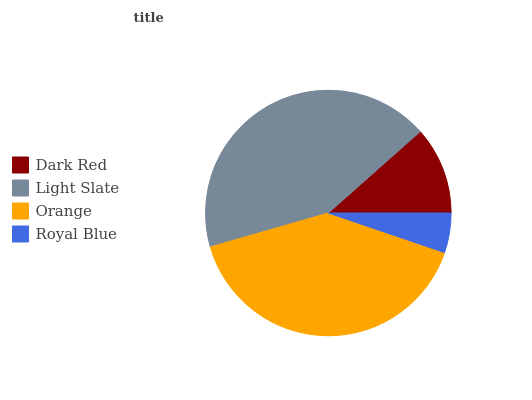Is Royal Blue the minimum?
Answer yes or no. Yes. Is Light Slate the maximum?
Answer yes or no. Yes. Is Orange the minimum?
Answer yes or no. No. Is Orange the maximum?
Answer yes or no. No. Is Light Slate greater than Orange?
Answer yes or no. Yes. Is Orange less than Light Slate?
Answer yes or no. Yes. Is Orange greater than Light Slate?
Answer yes or no. No. Is Light Slate less than Orange?
Answer yes or no. No. Is Orange the high median?
Answer yes or no. Yes. Is Dark Red the low median?
Answer yes or no. Yes. Is Light Slate the high median?
Answer yes or no. No. Is Orange the low median?
Answer yes or no. No. 